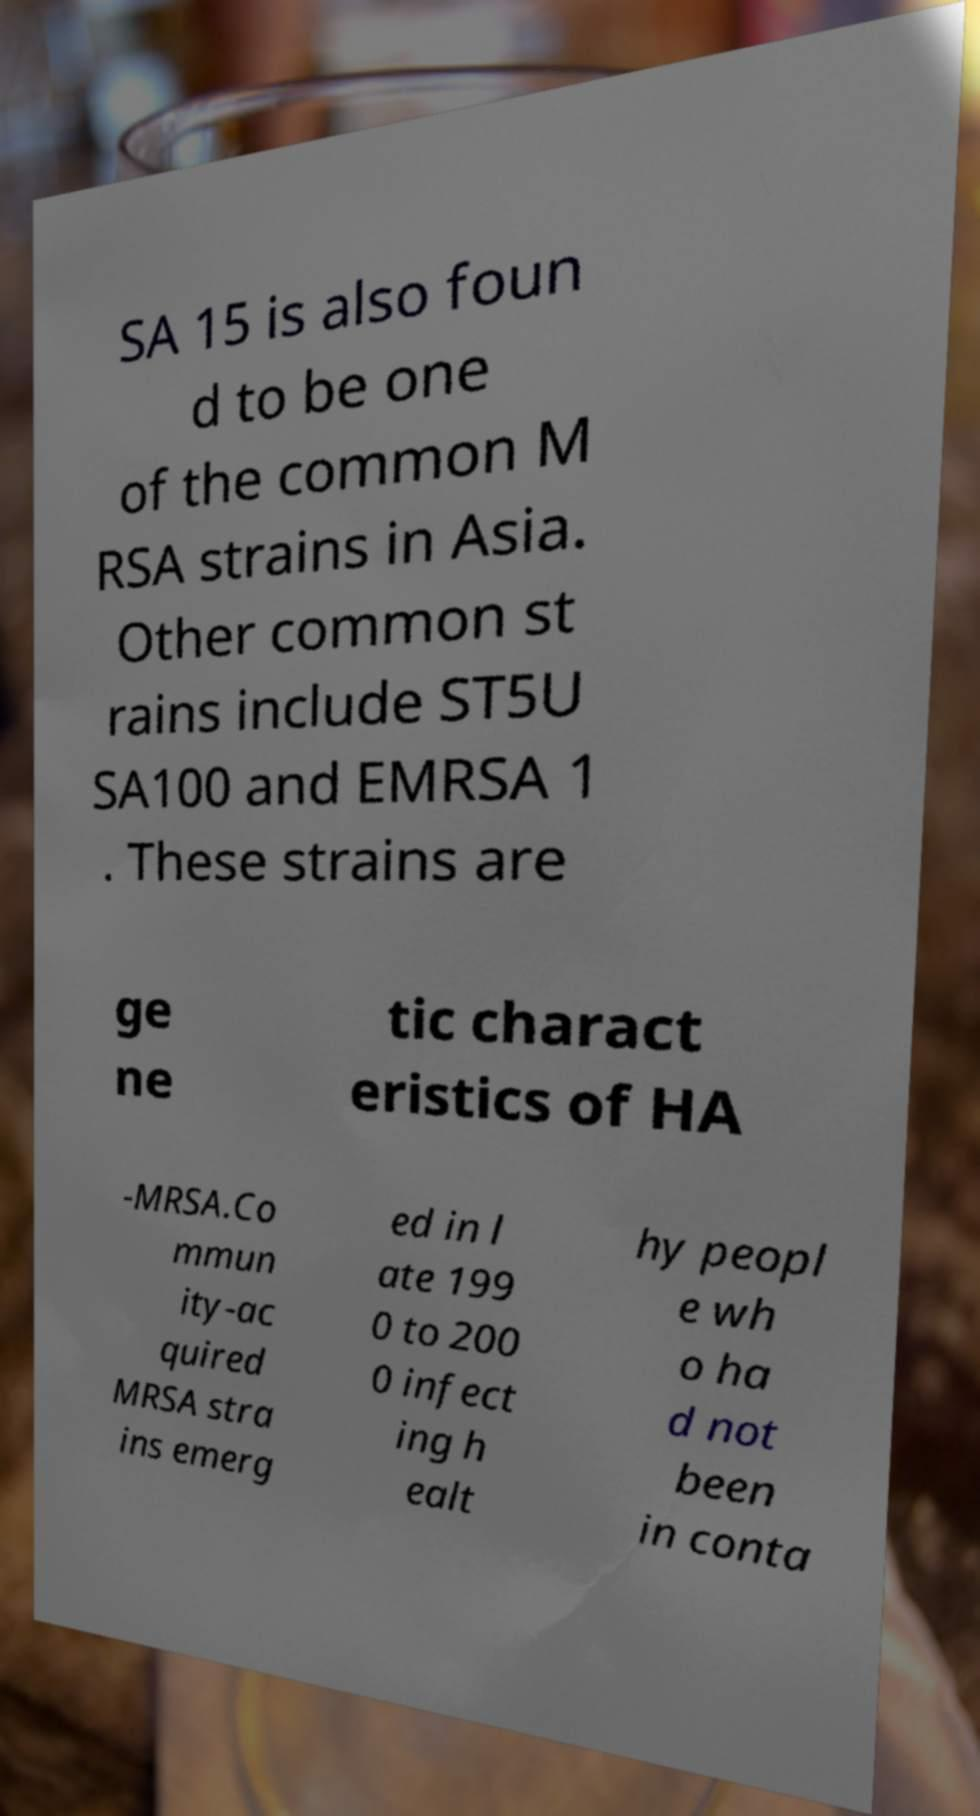I need the written content from this picture converted into text. Can you do that? SA 15 is also foun d to be one of the common M RSA strains in Asia. Other common st rains include ST5U SA100 and EMRSA 1 . These strains are ge ne tic charact eristics of HA -MRSA.Co mmun ity-ac quired MRSA stra ins emerg ed in l ate 199 0 to 200 0 infect ing h ealt hy peopl e wh o ha d not been in conta 